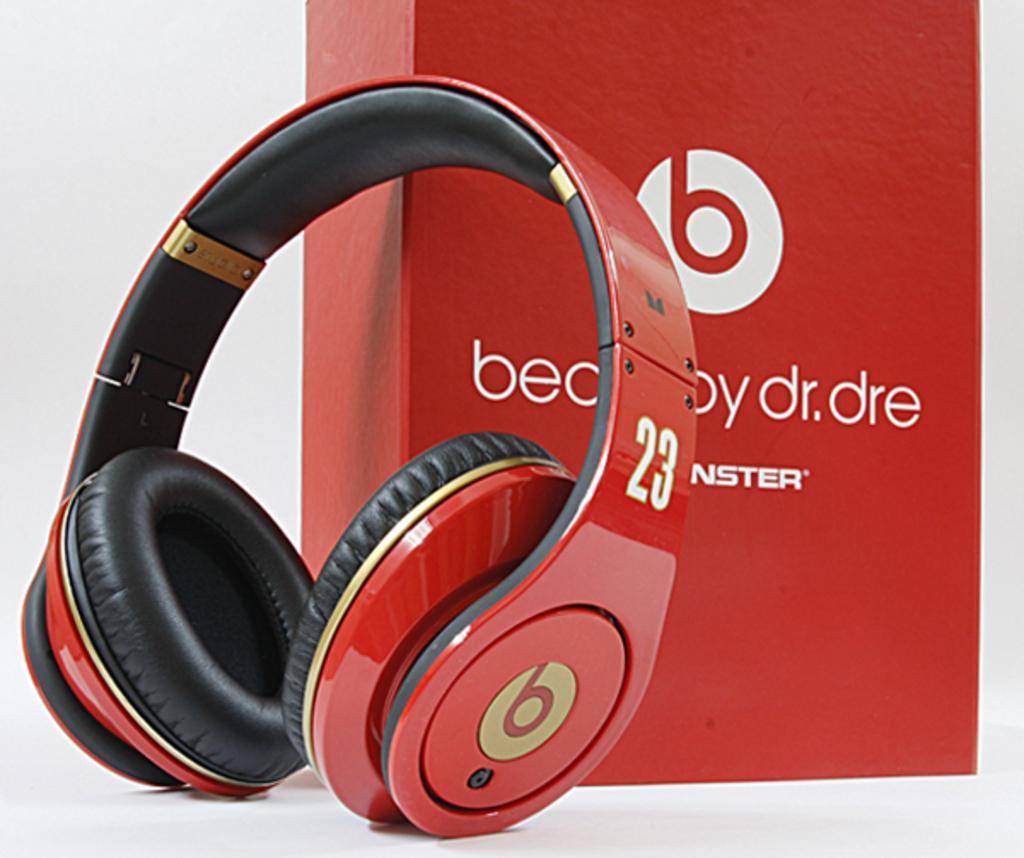Describe this image in one or two sentences. In the picture there is a wireless headset kept beside a red box. 